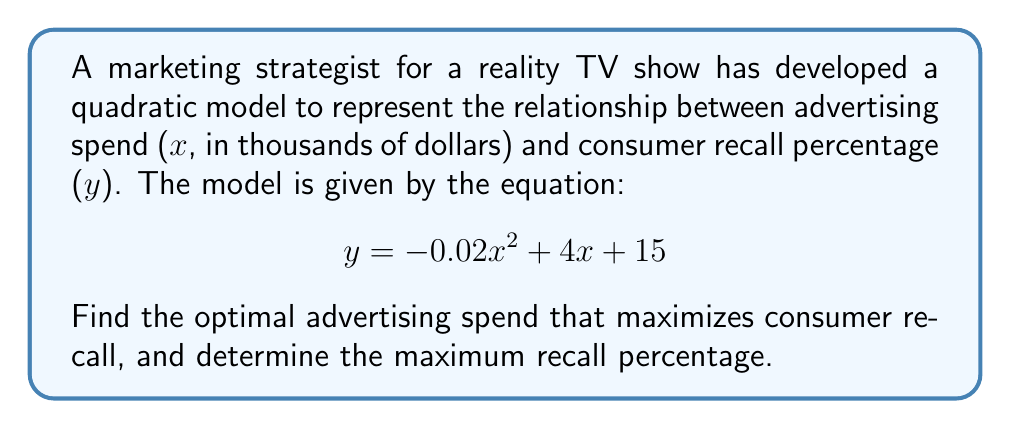Help me with this question. To solve this problem, we need to find the roots of the derivative of the given quadratic equation. This will give us the vertex of the parabola, which represents the optimal advertising spend and maximum recall percentage.

1. First, let's find the derivative of the equation:
   $$ \frac{dy}{dx} = -0.04x + 4 $$

2. Set the derivative equal to zero to find the critical point:
   $$ -0.04x + 4 = 0 $$

3. Solve for x:
   $$ -0.04x = -4 $$
   $$ x = \frac{-4}{-0.04} = 100 $$

4. The x-coordinate of the vertex (optimal advertising spend) is 100 thousand dollars.

5. To find the maximum recall percentage, substitute x = 100 into the original equation:
   $$ y = -0.02(100)^2 + 4(100) + 15 $$
   $$ y = -200 + 400 + 15 $$
   $$ y = 215 $$

Therefore, the maximum recall percentage is 215%.

Note: While a recall percentage over 100% is not realistic, this mathematical model provides this result. In practice, the model would need to be adjusted or interpreted within realistic bounds.
Answer: The optimal advertising spend is $100,000, which results in a maximum consumer recall of 215%. 